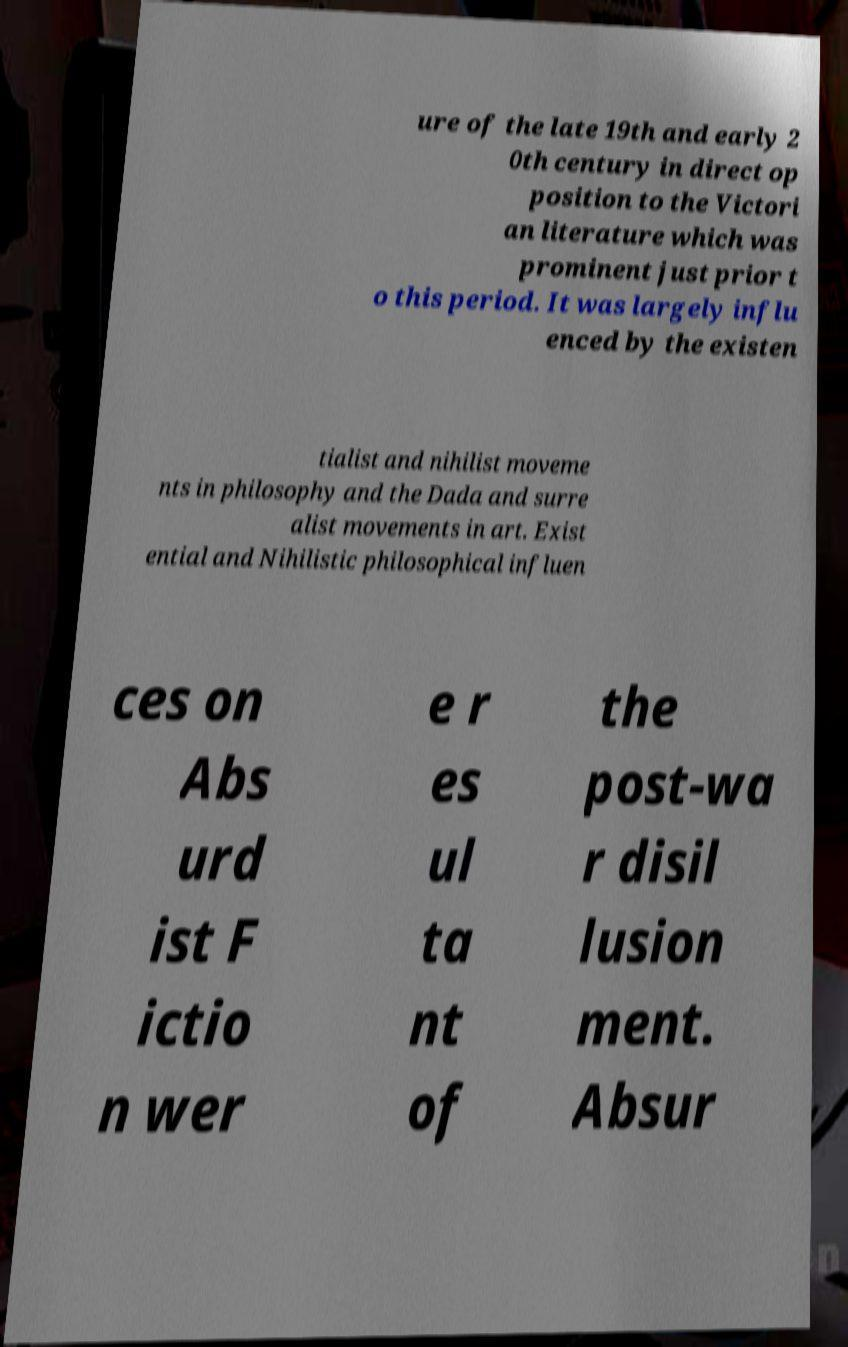For documentation purposes, I need the text within this image transcribed. Could you provide that? ure of the late 19th and early 2 0th century in direct op position to the Victori an literature which was prominent just prior t o this period. It was largely influ enced by the existen tialist and nihilist moveme nts in philosophy and the Dada and surre alist movements in art. Exist ential and Nihilistic philosophical influen ces on Abs urd ist F ictio n wer e r es ul ta nt of the post-wa r disil lusion ment. Absur 